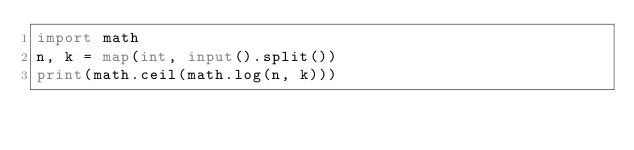Convert code to text. <code><loc_0><loc_0><loc_500><loc_500><_Python_>import math
n, k = map(int, input().split())
print(math.ceil(math.log(n, k)))</code> 